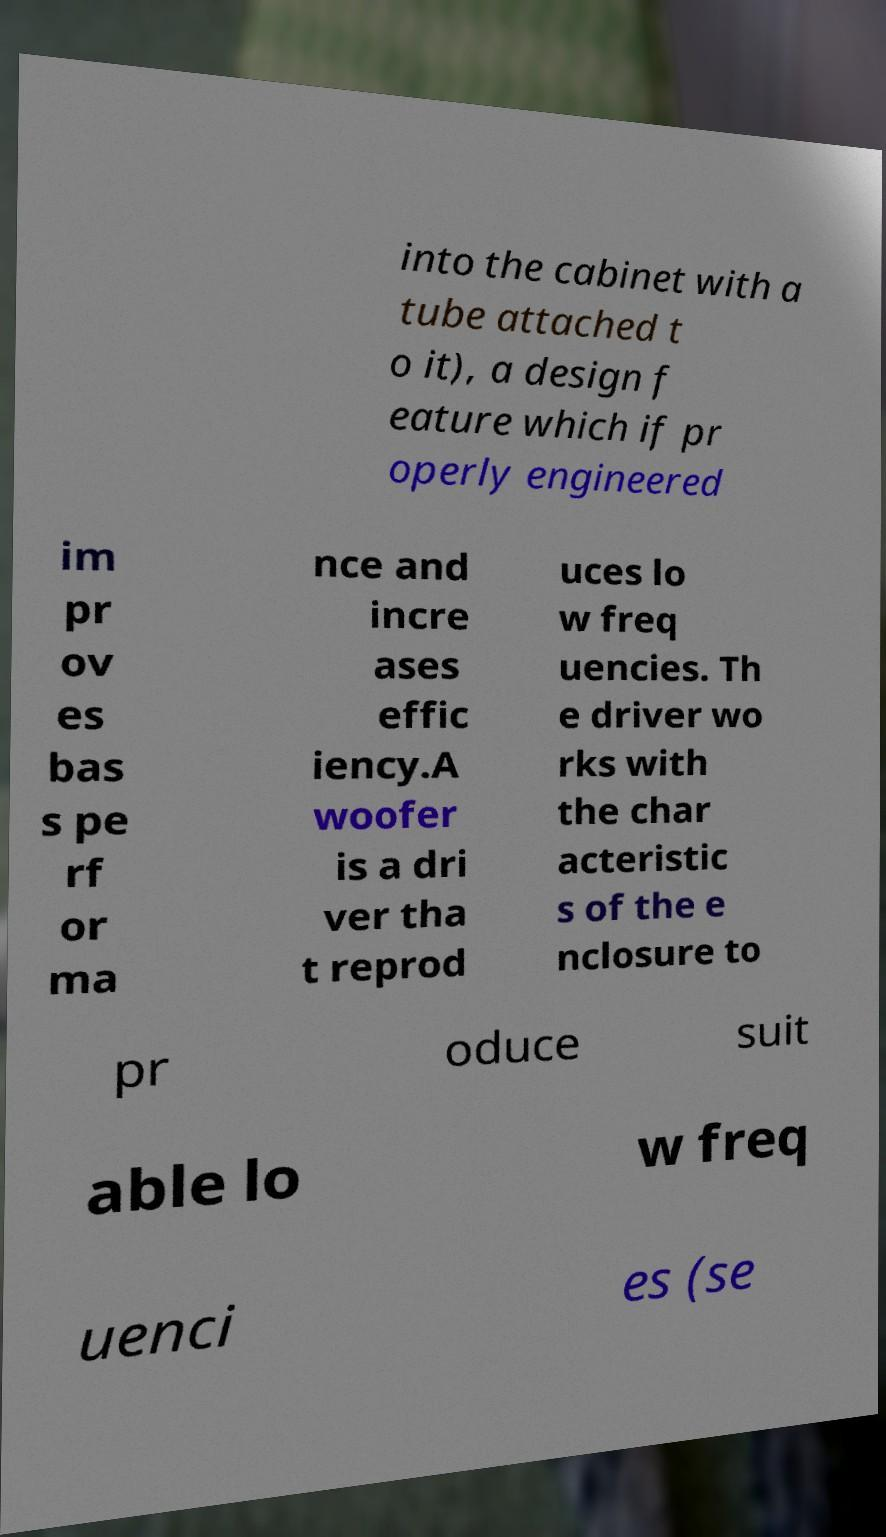Can you accurately transcribe the text from the provided image for me? into the cabinet with a tube attached t o it), a design f eature which if pr operly engineered im pr ov es bas s pe rf or ma nce and incre ases effic iency.A woofer is a dri ver tha t reprod uces lo w freq uencies. Th e driver wo rks with the char acteristic s of the e nclosure to pr oduce suit able lo w freq uenci es (se 